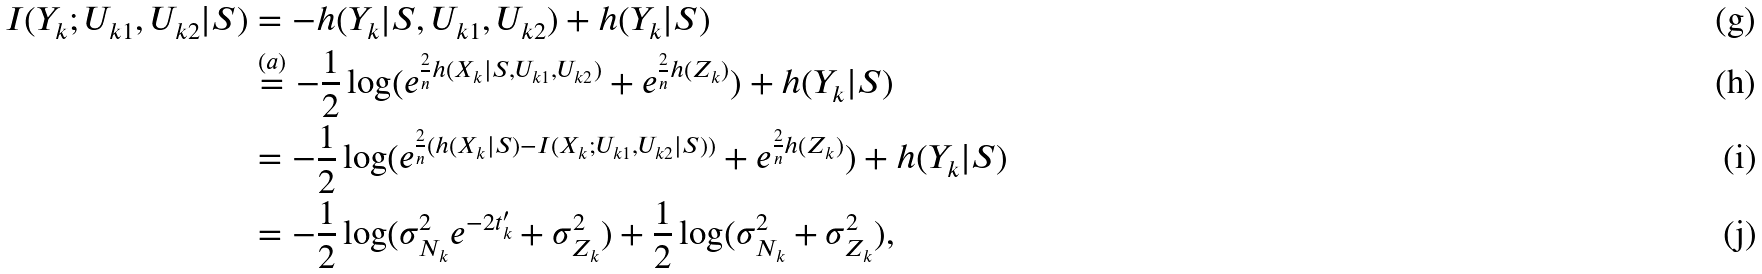Convert formula to latex. <formula><loc_0><loc_0><loc_500><loc_500>I ( Y _ { k } ; U _ { k 1 } , U _ { k 2 } | S ) & = - h ( Y _ { k } | S , U _ { k 1 } , U _ { k 2 } ) + h ( Y _ { k } | S ) \\ & \overset { ( a ) } { = } - \frac { 1 } { 2 } \log ( e ^ { \frac { 2 } { n } h ( X _ { k } | S , U _ { k 1 } , U _ { k 2 } ) } + e ^ { \frac { 2 } { n } h ( Z _ { k } ) } ) + h ( Y _ { k } | S ) \\ & = - \frac { 1 } { 2 } \log ( e ^ { \frac { 2 } { n } ( h ( X _ { k } | S ) - I ( X _ { k } ; U _ { k 1 } , U _ { k 2 } | S ) ) } + e ^ { \frac { 2 } { n } h ( Z _ { k } ) } ) + h ( Y _ { k } | S ) \\ & = - \frac { 1 } { 2 } \log ( \sigma _ { N _ { k } } ^ { 2 } e ^ { - 2 t _ { k } ^ { \prime } } + \sigma _ { Z _ { k } } ^ { 2 } ) + \frac { 1 } { 2 } \log ( \sigma _ { N _ { k } } ^ { 2 } + \sigma _ { Z _ { k } } ^ { 2 } ) ,</formula> 